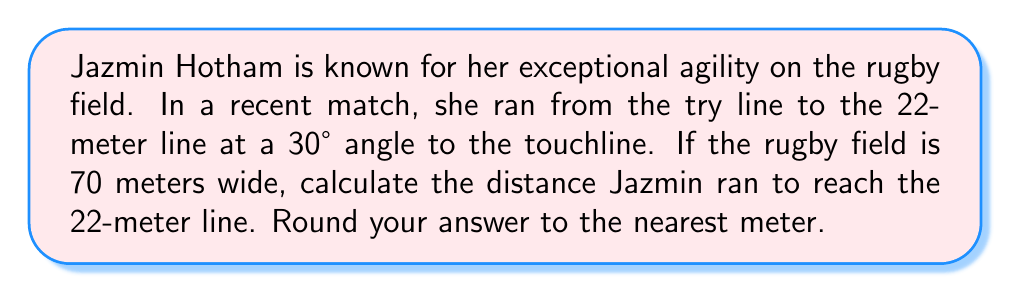Could you help me with this problem? Let's approach this step-by-step using trigonometry:

1) First, let's visualize the problem:

[asy]
unitsize(2mm);
draw((0,0)--(70,0)--(70,22)--(0,22)--cycle);
draw((0,0)--(35,22));
label("Try line", (35,-3), S);
label("22m line", (35,25), N);
label("Touchline", (-3,11), W);
label("30°", (5,3), NE);
label("x", (18,11), NW);
label("22m", (72,11), E);
label("y", (35,3), S);
[/asy]

2) We can see that this forms a right-angled triangle. We know:
   - The angle between Jazmin's path and the touchline is 30°
   - The opposite side of this triangle is 22 meters (the distance to the 22m line)
   - We need to find the hypotenuse of this triangle, which is Jazmin's running distance

3) We can use the sine ratio to solve this:

   $\sin(30°) = \frac{\text{opposite}}{\text{hypotenuse}} = \frac{22}{\text{distance}}$

4) Rearranging this equation:

   $\text{distance} = \frac{22}{\sin(30°)}$

5) Now let's calculate:
   
   $\text{distance} = \frac{22}{\sin(30°)} \approx \frac{22}{0.5} = 44$ meters

6) Rounding to the nearest meter as requested, we get 44 meters.
Answer: 44 meters 